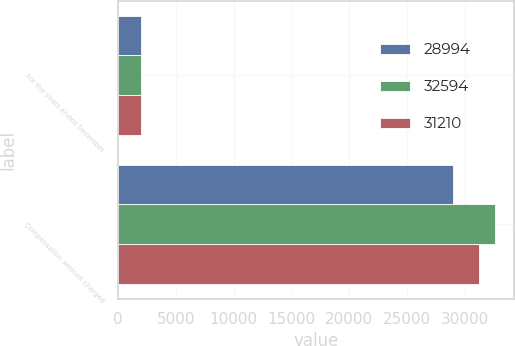Convert chart to OTSL. <chart><loc_0><loc_0><loc_500><loc_500><stacked_bar_chart><ecel><fcel>For the years ended December<fcel>Compensation amount charged<nl><fcel>28994<fcel>2014<fcel>28994<nl><fcel>32594<fcel>2013<fcel>32594<nl><fcel>31210<fcel>2012<fcel>31210<nl></chart> 